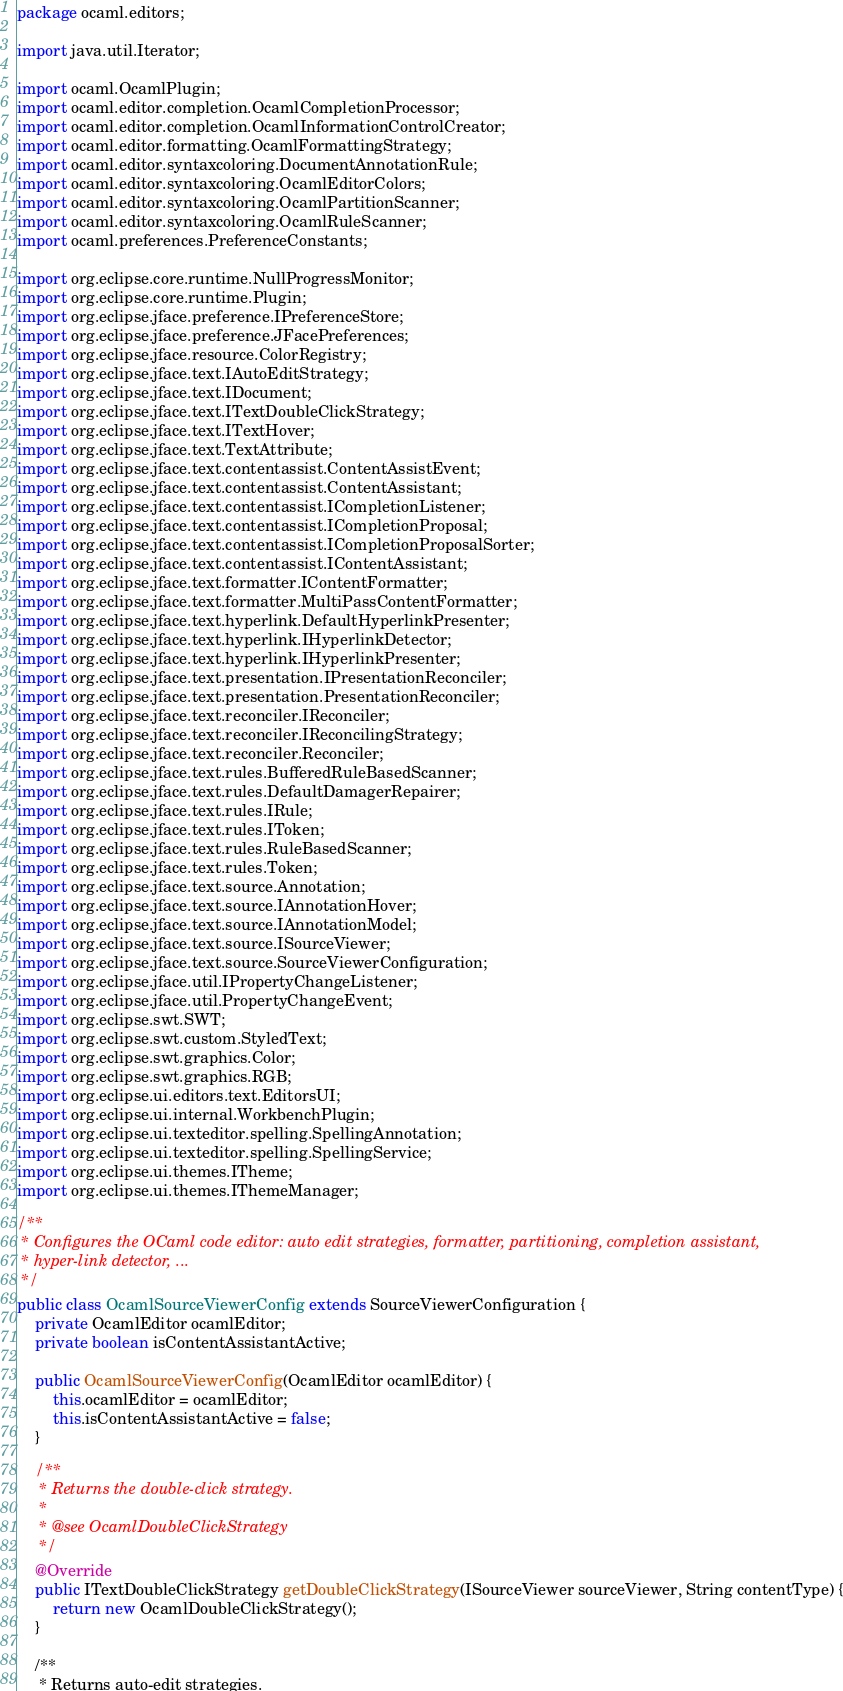Convert code to text. <code><loc_0><loc_0><loc_500><loc_500><_Java_>package ocaml.editors;

import java.util.Iterator;

import ocaml.OcamlPlugin;
import ocaml.editor.completion.OcamlCompletionProcessor;
import ocaml.editor.completion.OcamlInformationControlCreator;
import ocaml.editor.formatting.OcamlFormattingStrategy;
import ocaml.editor.syntaxcoloring.DocumentAnnotationRule;
import ocaml.editor.syntaxcoloring.OcamlEditorColors;
import ocaml.editor.syntaxcoloring.OcamlPartitionScanner;
import ocaml.editor.syntaxcoloring.OcamlRuleScanner;
import ocaml.preferences.PreferenceConstants;

import org.eclipse.core.runtime.NullProgressMonitor;
import org.eclipse.core.runtime.Plugin;
import org.eclipse.jface.preference.IPreferenceStore;
import org.eclipse.jface.preference.JFacePreferences;
import org.eclipse.jface.resource.ColorRegistry;
import org.eclipse.jface.text.IAutoEditStrategy;
import org.eclipse.jface.text.IDocument;
import org.eclipse.jface.text.ITextDoubleClickStrategy;
import org.eclipse.jface.text.ITextHover;
import org.eclipse.jface.text.TextAttribute;
import org.eclipse.jface.text.contentassist.ContentAssistEvent;
import org.eclipse.jface.text.contentassist.ContentAssistant;
import org.eclipse.jface.text.contentassist.ICompletionListener;
import org.eclipse.jface.text.contentassist.ICompletionProposal;
import org.eclipse.jface.text.contentassist.ICompletionProposalSorter;
import org.eclipse.jface.text.contentassist.IContentAssistant;
import org.eclipse.jface.text.formatter.IContentFormatter;
import org.eclipse.jface.text.formatter.MultiPassContentFormatter;
import org.eclipse.jface.text.hyperlink.DefaultHyperlinkPresenter;
import org.eclipse.jface.text.hyperlink.IHyperlinkDetector;
import org.eclipse.jface.text.hyperlink.IHyperlinkPresenter;
import org.eclipse.jface.text.presentation.IPresentationReconciler;
import org.eclipse.jface.text.presentation.PresentationReconciler;
import org.eclipse.jface.text.reconciler.IReconciler;
import org.eclipse.jface.text.reconciler.IReconcilingStrategy;
import org.eclipse.jface.text.reconciler.Reconciler;
import org.eclipse.jface.text.rules.BufferedRuleBasedScanner;
import org.eclipse.jface.text.rules.DefaultDamagerRepairer;
import org.eclipse.jface.text.rules.IRule;
import org.eclipse.jface.text.rules.IToken;
import org.eclipse.jface.text.rules.RuleBasedScanner;
import org.eclipse.jface.text.rules.Token;
import org.eclipse.jface.text.source.Annotation;
import org.eclipse.jface.text.source.IAnnotationHover;
import org.eclipse.jface.text.source.IAnnotationModel;
import org.eclipse.jface.text.source.ISourceViewer;
import org.eclipse.jface.text.source.SourceViewerConfiguration;
import org.eclipse.jface.util.IPropertyChangeListener;
import org.eclipse.jface.util.PropertyChangeEvent;
import org.eclipse.swt.SWT;
import org.eclipse.swt.custom.StyledText;
import org.eclipse.swt.graphics.Color;
import org.eclipse.swt.graphics.RGB;
import org.eclipse.ui.editors.text.EditorsUI;
import org.eclipse.ui.internal.WorkbenchPlugin;
import org.eclipse.ui.texteditor.spelling.SpellingAnnotation;
import org.eclipse.ui.texteditor.spelling.SpellingService;
import org.eclipse.ui.themes.ITheme;
import org.eclipse.ui.themes.IThemeManager;

/**
 * Configures the OCaml code editor: auto edit strategies, formatter, partitioning, completion assistant,
 * hyper-link detector, ...
 */
public class OcamlSourceViewerConfig extends SourceViewerConfiguration {
	private OcamlEditor ocamlEditor;
	private boolean isContentAssistantActive;

	public OcamlSourceViewerConfig(OcamlEditor ocamlEditor) {
		this.ocamlEditor = ocamlEditor;
		this.isContentAssistantActive = false;
	}

	/**
	 * Returns the double-click strategy.
	 * 
	 * @see OcamlDoubleClickStrategy
	 */
	@Override
	public ITextDoubleClickStrategy getDoubleClickStrategy(ISourceViewer sourceViewer, String contentType) {
		return new OcamlDoubleClickStrategy();
	}

	/**
	 * Returns auto-edit strategies.</code> 